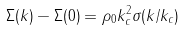<formula> <loc_0><loc_0><loc_500><loc_500>\Sigma ( k ) - \Sigma ( 0 ) = \rho _ { 0 } k _ { c } ^ { 2 } \sigma ( k / k _ { c } )</formula> 